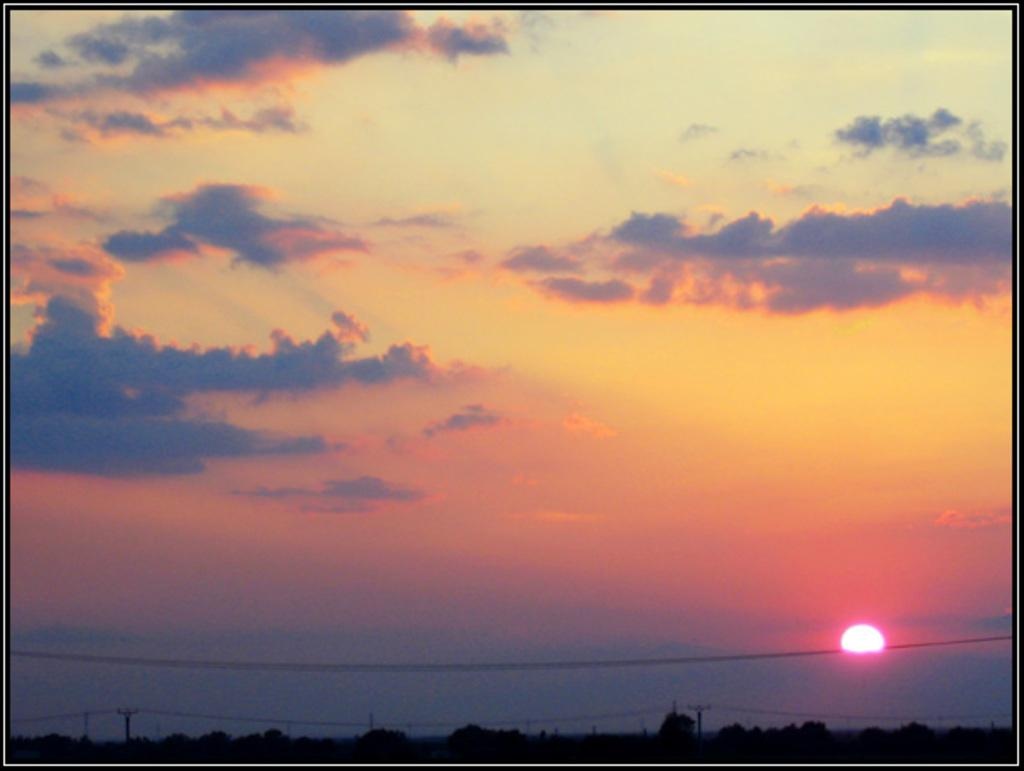What is visible in the sky in the image? The sky is visible in the image, and the sun is also visible. What objects can be seen supporting the wires in the image? There are poles in the image that support the wires. Can you describe the lighting conditions in the image? The image appears to be a bit dark. How does the pollution affect the harbor in the image? There is no harbor or pollution present in the image. Can you tell me how the person in the image is reacting to the situation? There is no person present in the image, so we cannot determine their reaction. 